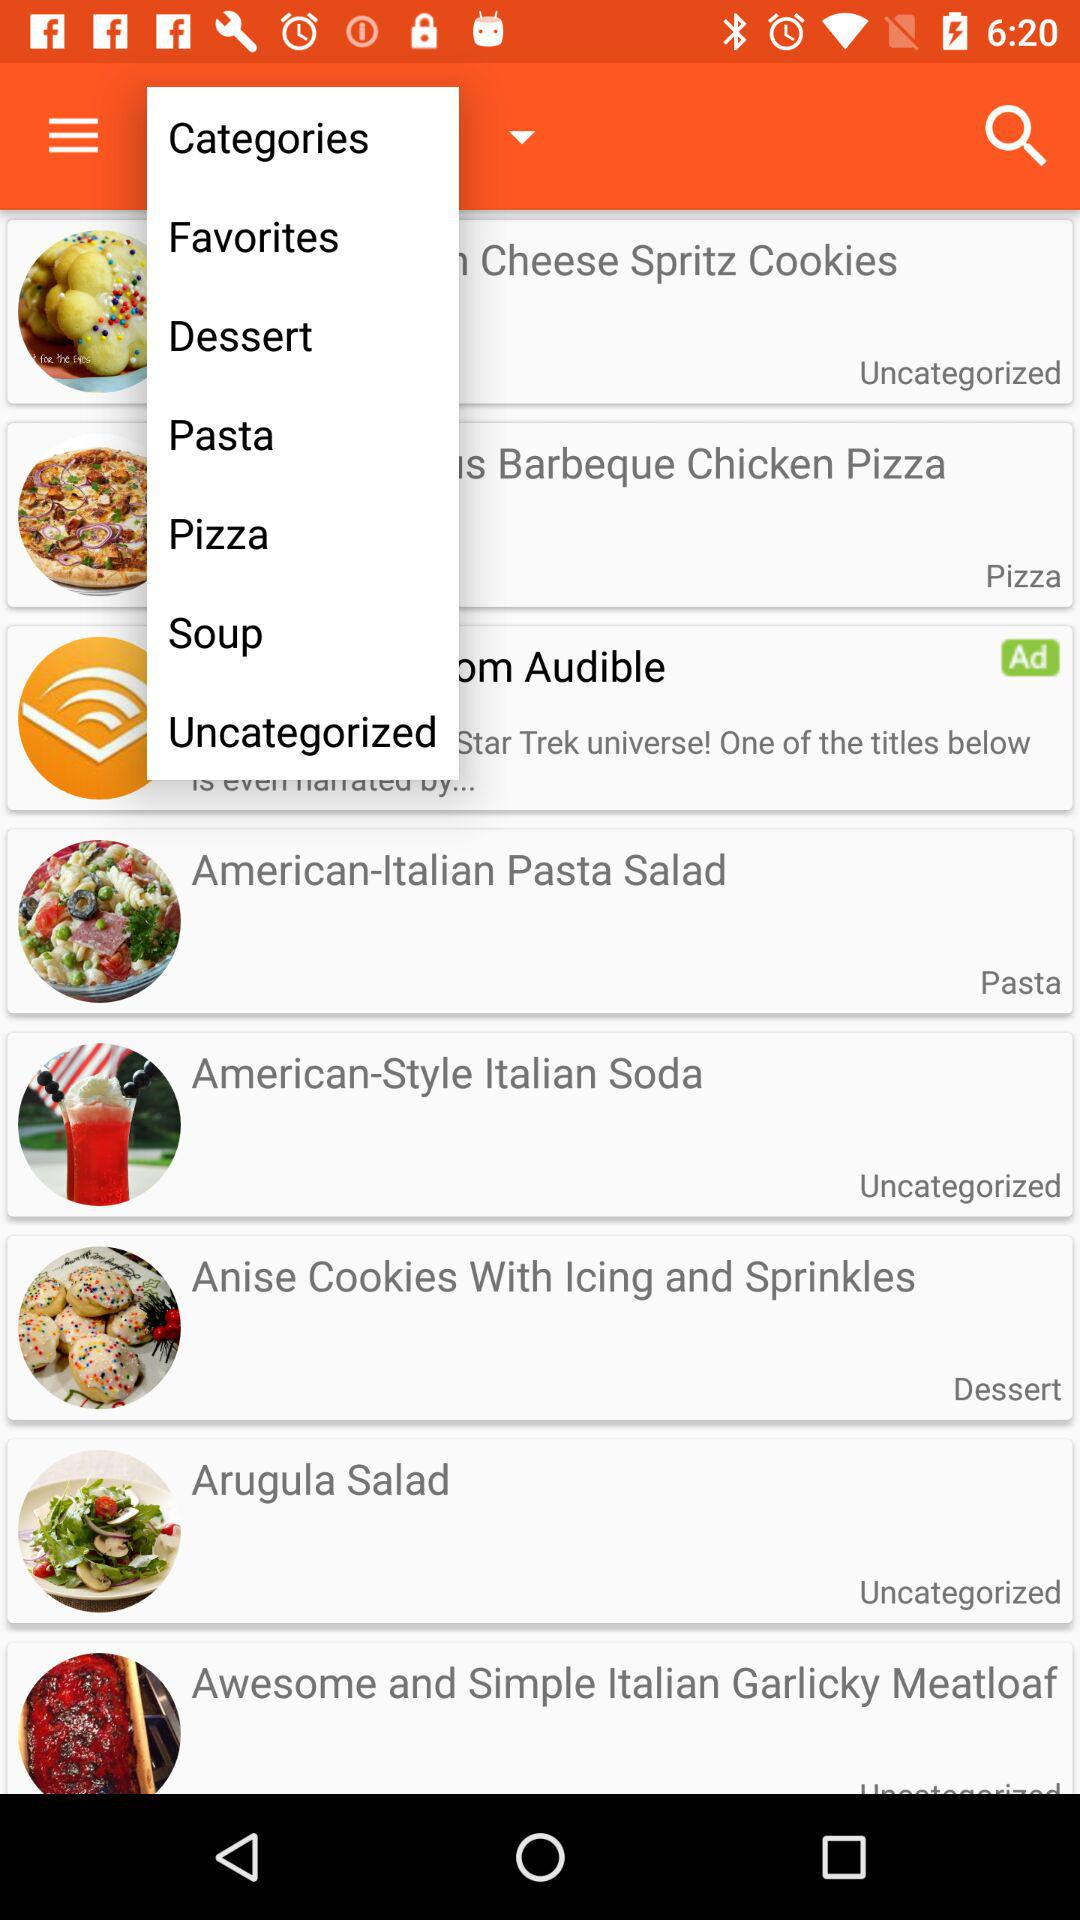What is the category of "American-Italian Pasta Salad"? The category is "Pasta". 